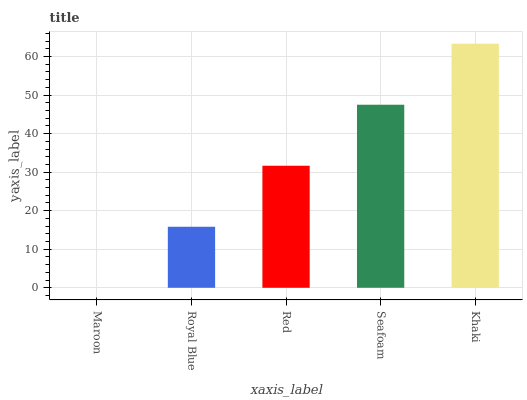Is Maroon the minimum?
Answer yes or no. Yes. Is Khaki the maximum?
Answer yes or no. Yes. Is Royal Blue the minimum?
Answer yes or no. No. Is Royal Blue the maximum?
Answer yes or no. No. Is Royal Blue greater than Maroon?
Answer yes or no. Yes. Is Maroon less than Royal Blue?
Answer yes or no. Yes. Is Maroon greater than Royal Blue?
Answer yes or no. No. Is Royal Blue less than Maroon?
Answer yes or no. No. Is Red the high median?
Answer yes or no. Yes. Is Red the low median?
Answer yes or no. Yes. Is Maroon the high median?
Answer yes or no. No. Is Maroon the low median?
Answer yes or no. No. 